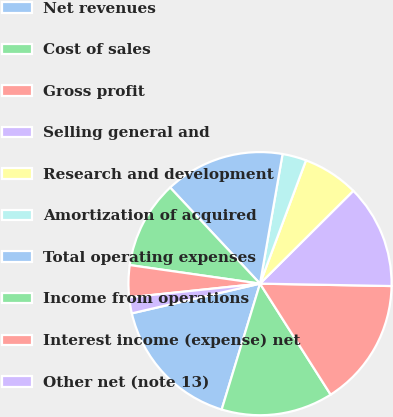Convert chart to OTSL. <chart><loc_0><loc_0><loc_500><loc_500><pie_chart><fcel>Net revenues<fcel>Cost of sales<fcel>Gross profit<fcel>Selling general and<fcel>Research and development<fcel>Amortization of acquired<fcel>Total operating expenses<fcel>Income from operations<fcel>Interest income (expense) net<fcel>Other net (note 13)<nl><fcel>16.67%<fcel>13.73%<fcel>15.69%<fcel>12.75%<fcel>6.86%<fcel>2.94%<fcel>14.71%<fcel>10.78%<fcel>3.92%<fcel>1.96%<nl></chart> 